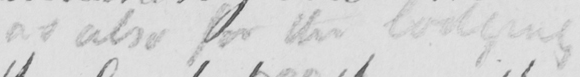Transcribe the text shown in this historical manuscript line. as also for the lodging 